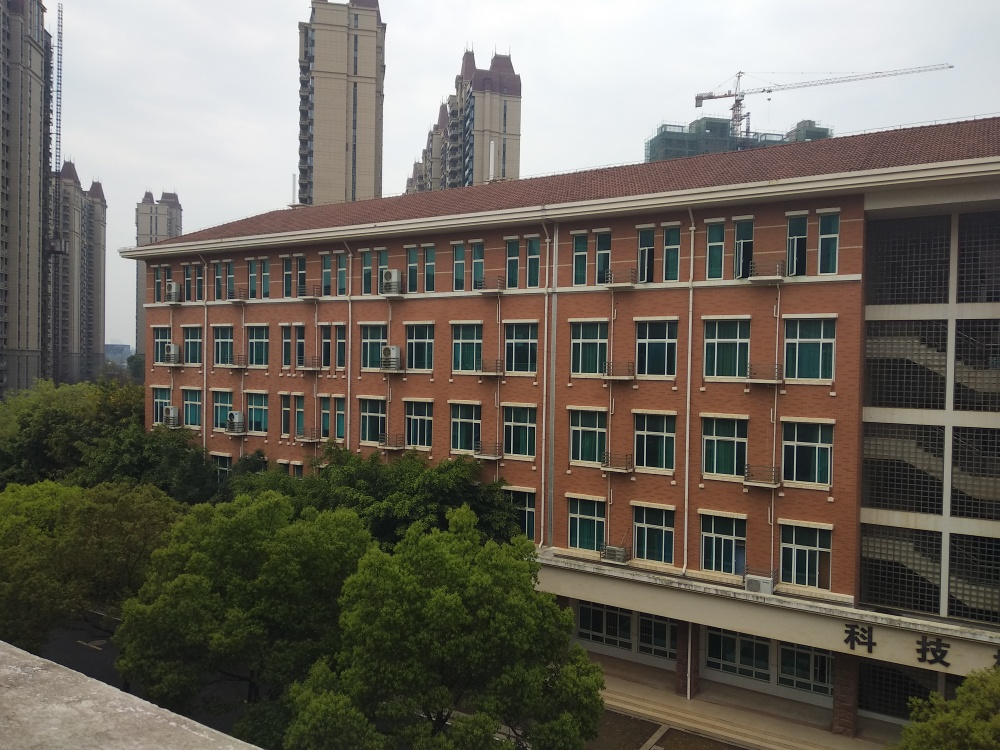What is the architectural style of the building? The building in the image exhibits features of modern architectural style with its functional design elements such as the repeated window patterns and the use of external air conditioning units. The brick facade adds a touch of traditional craftsmanship, creating a blend of contemporary and classic styles. 